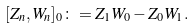Convert formula to latex. <formula><loc_0><loc_0><loc_500><loc_500>[ Z _ { n } , W _ { n } ] _ { 0 } \colon = Z _ { 1 } W _ { 0 } - Z _ { 0 } W _ { 1 } .</formula> 